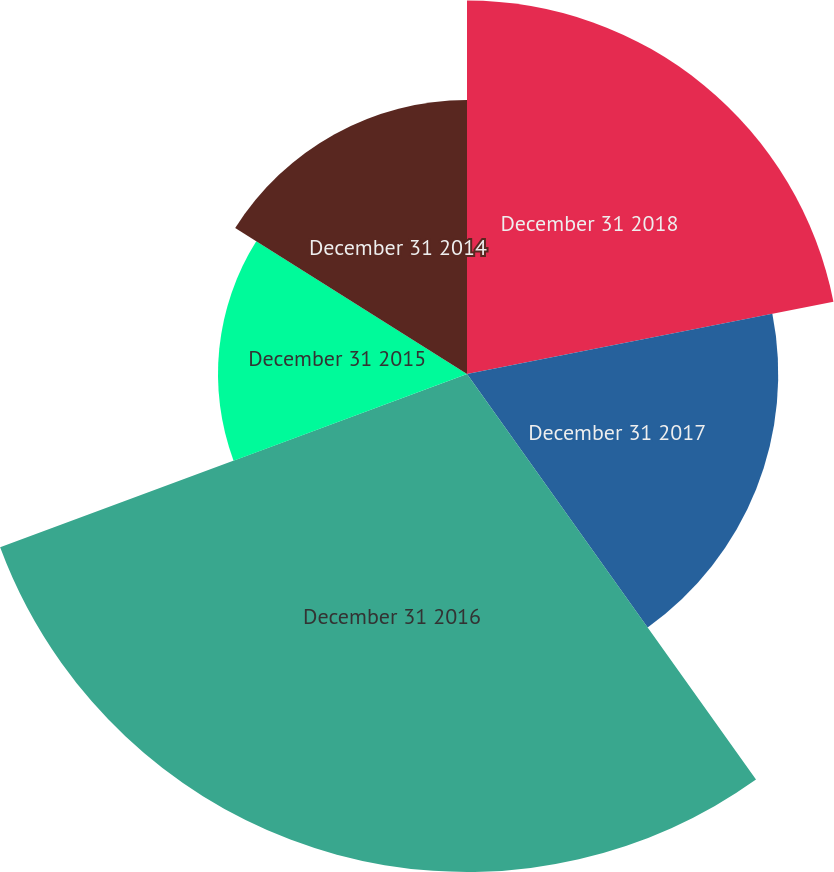<chart> <loc_0><loc_0><loc_500><loc_500><pie_chart><fcel>December 31 2018<fcel>December 31 2017<fcel>December 31 2016<fcel>December 31 2015<fcel>December 31 2014<nl><fcel>21.9%<fcel>18.25%<fcel>29.2%<fcel>14.6%<fcel>16.06%<nl></chart> 